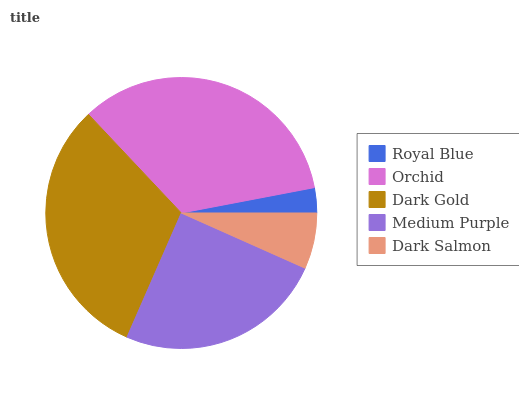Is Royal Blue the minimum?
Answer yes or no. Yes. Is Orchid the maximum?
Answer yes or no. Yes. Is Dark Gold the minimum?
Answer yes or no. No. Is Dark Gold the maximum?
Answer yes or no. No. Is Orchid greater than Dark Gold?
Answer yes or no. Yes. Is Dark Gold less than Orchid?
Answer yes or no. Yes. Is Dark Gold greater than Orchid?
Answer yes or no. No. Is Orchid less than Dark Gold?
Answer yes or no. No. Is Medium Purple the high median?
Answer yes or no. Yes. Is Medium Purple the low median?
Answer yes or no. Yes. Is Dark Gold the high median?
Answer yes or no. No. Is Dark Salmon the low median?
Answer yes or no. No. 